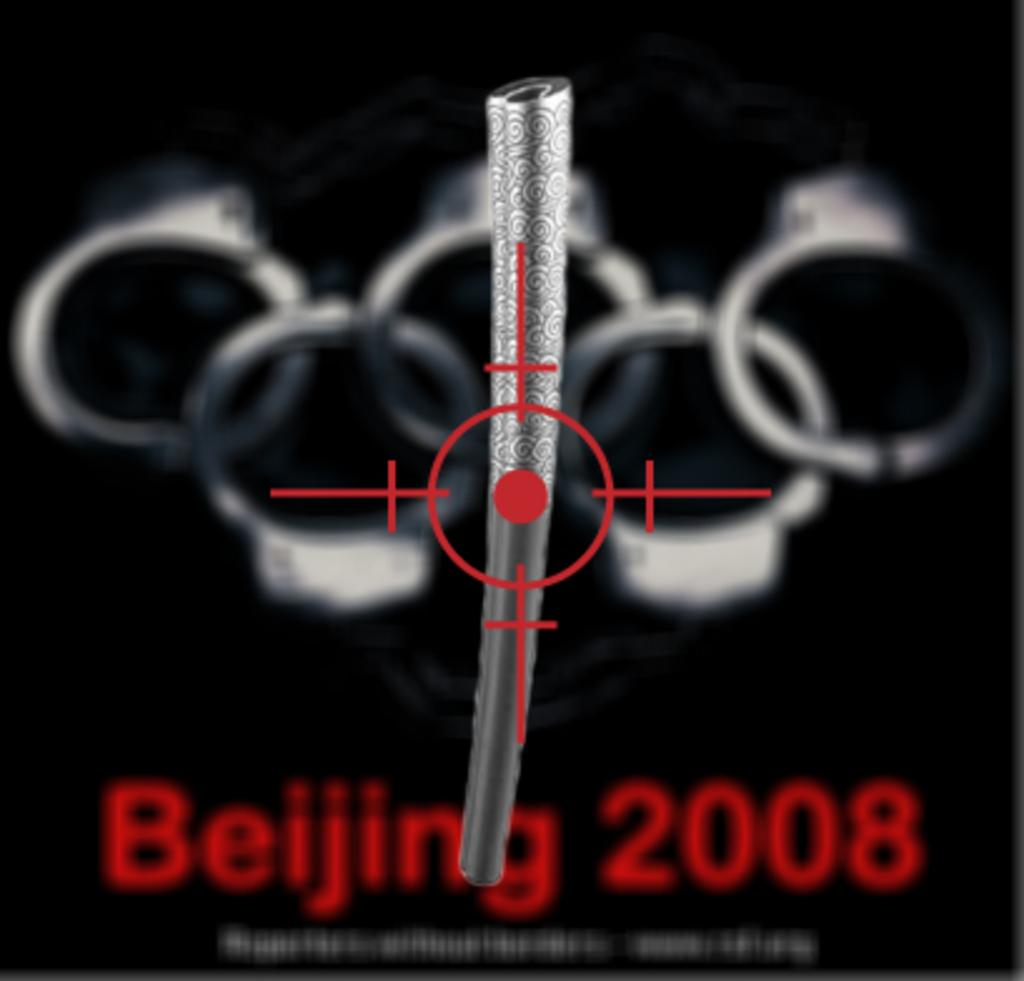<image>
Render a clear and concise summary of the photo. Beijing 2008 sign on a paper with handcuffs in the background 